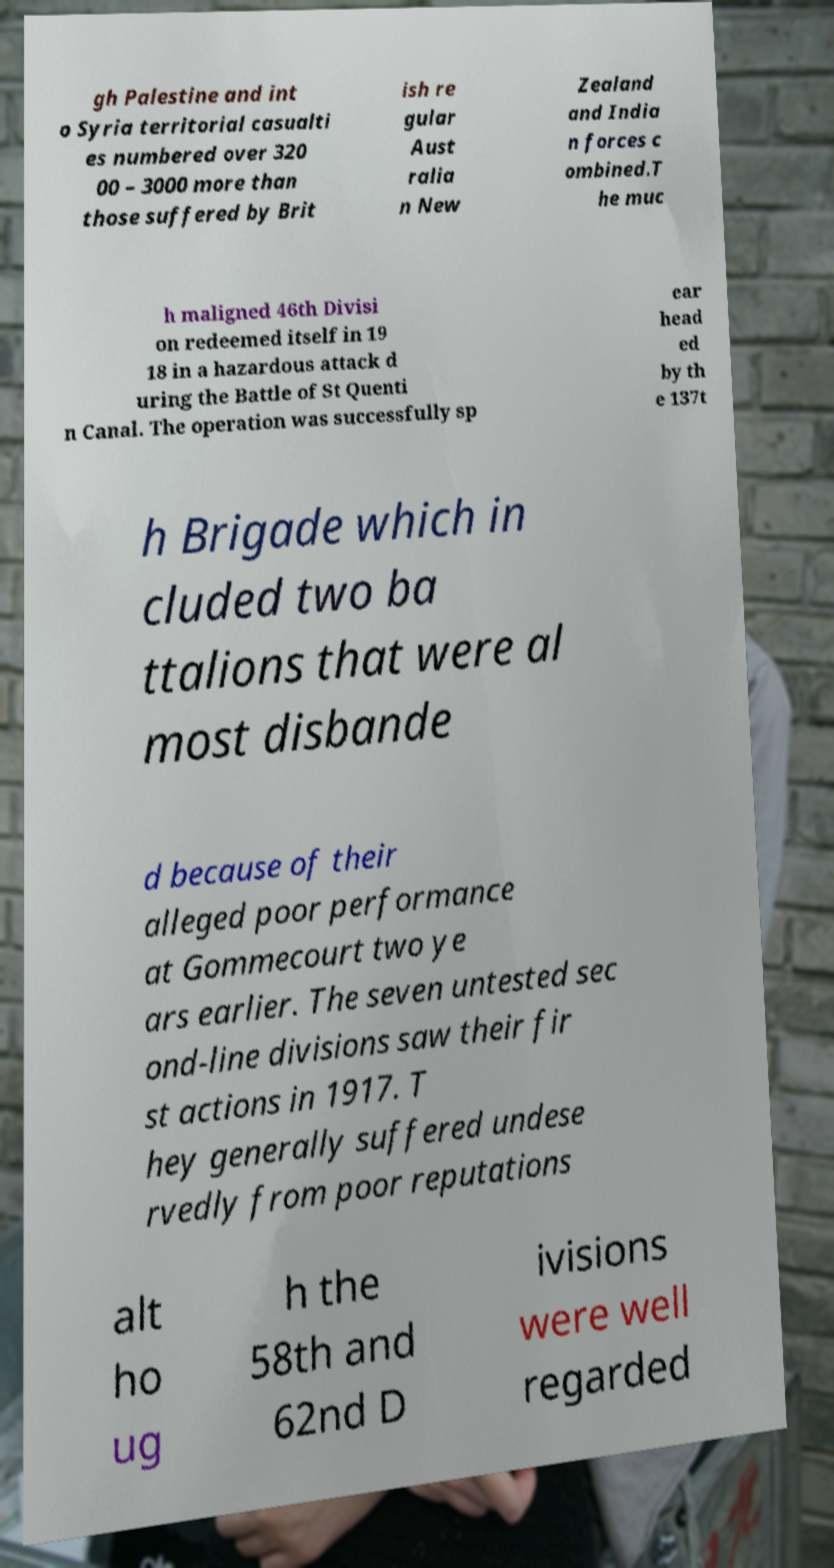There's text embedded in this image that I need extracted. Can you transcribe it verbatim? gh Palestine and int o Syria territorial casualti es numbered over 320 00 – 3000 more than those suffered by Brit ish re gular Aust ralia n New Zealand and India n forces c ombined.T he muc h maligned 46th Divisi on redeemed itself in 19 18 in a hazardous attack d uring the Battle of St Quenti n Canal. The operation was successfully sp ear head ed by th e 137t h Brigade which in cluded two ba ttalions that were al most disbande d because of their alleged poor performance at Gommecourt two ye ars earlier. The seven untested sec ond-line divisions saw their fir st actions in 1917. T hey generally suffered undese rvedly from poor reputations alt ho ug h the 58th and 62nd D ivisions were well regarded 